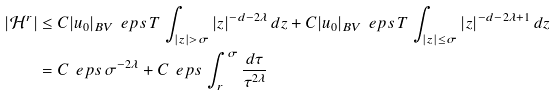Convert formula to latex. <formula><loc_0><loc_0><loc_500><loc_500>| \mathcal { H } ^ { r } | & \leq C | u _ { 0 } | _ { B V } \, \ e p s \, T \, \int _ { | z | > \sigma } | z | ^ { - d - 2 \lambda } \, d z + C | u _ { 0 } | _ { B V } \, \ e p s \, T \, \int _ { | z | \leq \sigma } | z | ^ { - d - 2 \lambda + 1 } \, d z \\ & = C \, \ e p s \, \sigma ^ { - 2 \lambda } + C \, \ e p s \, \int _ { r } ^ { \sigma } \frac { d \tau } { \tau ^ { 2 \lambda } }</formula> 